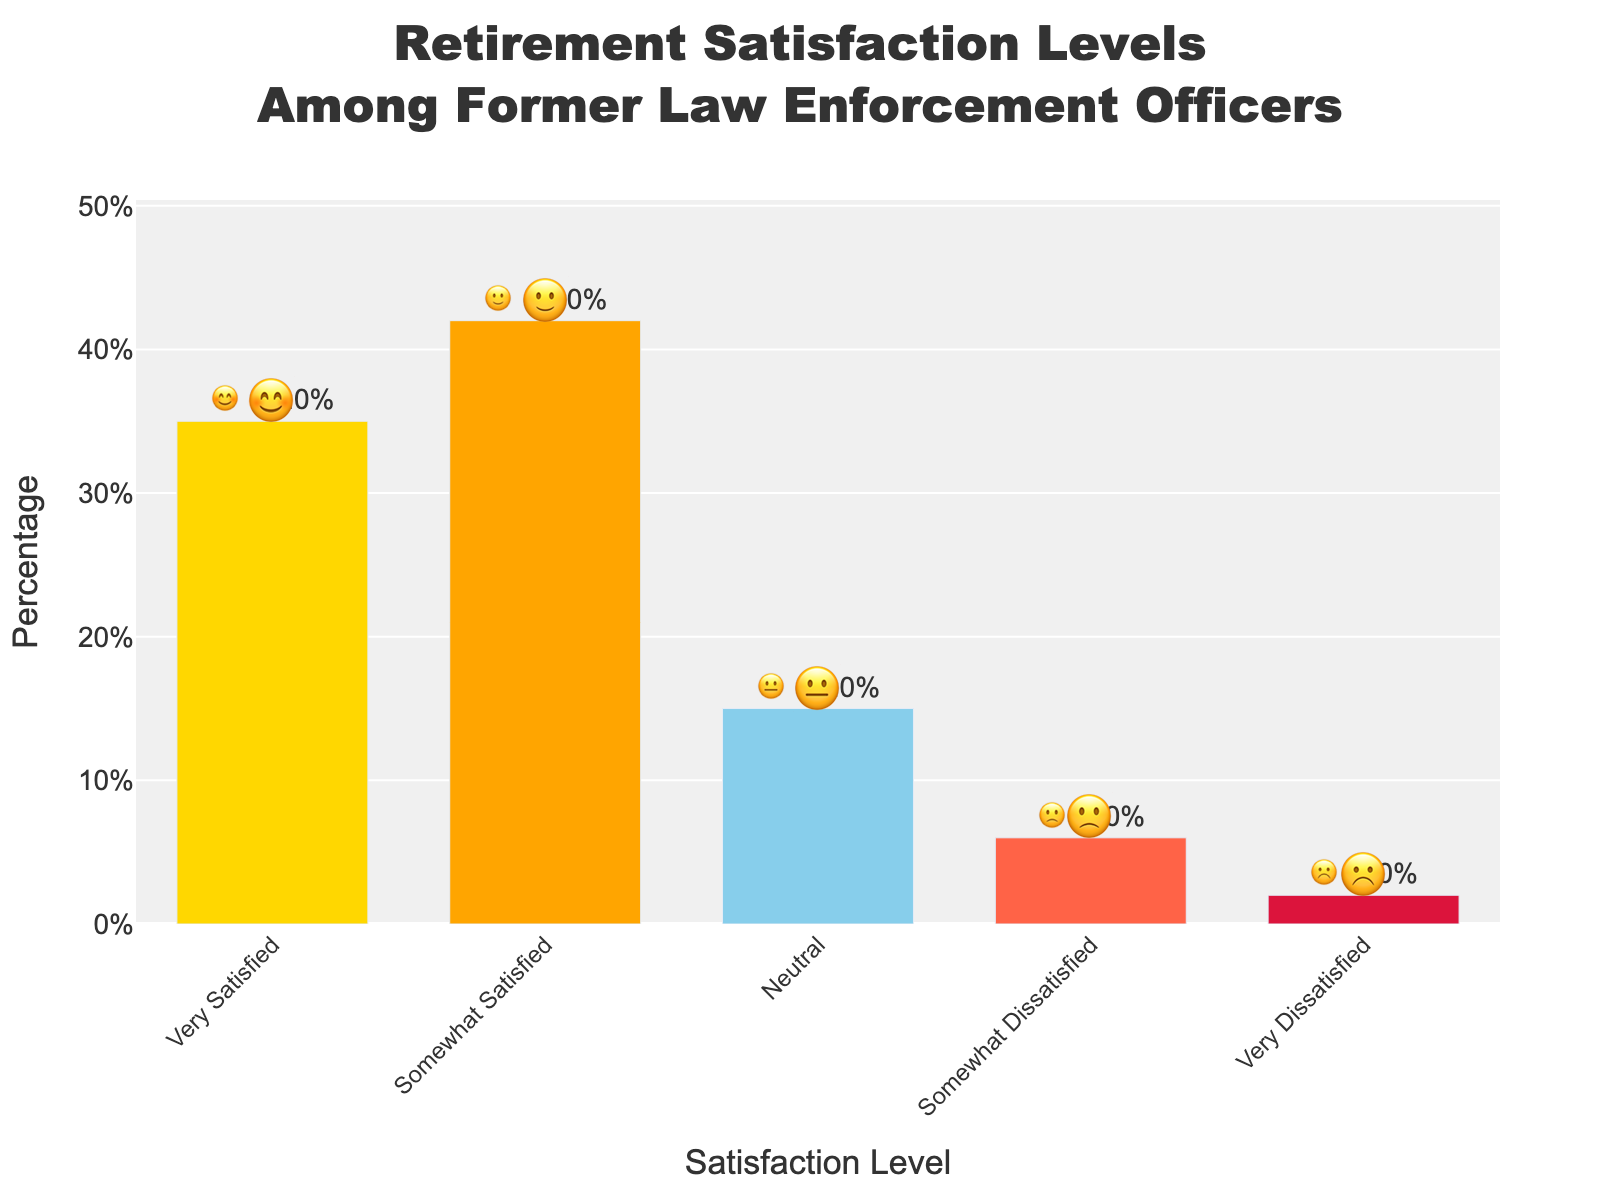What is the highest retirement satisfaction level among former law enforcement officers? The highest retirement satisfaction level can be seen by identifying the bar with the greatest height in the plot. The 'Very Satisfied' bar is highest, indicating it has the largest percentage.
Answer: Very Satisfied Which satisfaction level has the lowest percentage? The bar corresponding to the satisfaction level with the smallest height represents the lowest percentage. The 'Very Dissatisfied' bar is the shortest.
Answer: Very Dissatisfied What is the combined percentage of officers who are somewhat and very satisfied with their retirement? Adding the percentages for 'Somewhat Satisfied' and 'Very Satisfied', 42% and 35% respectively, gives the combined percentage.
Answer: 77% How much higher is the satisfaction of the 'Somewhat Satisfied' group compared to the 'Neutral' group? Subtract the percentage of the 'Neutral' group from the percentage of the 'Somewhat Satisfied' group (42% - 15% = 27%).
Answer: 27% What is the title of the chart? The title is displayed at the top of the chart. It reads, "Retirement Satisfaction Levels Among Former Law Enforcement Officers."
Answer: Retirement Satisfaction Levels Among Former Law Enforcement Officers Which two satisfaction levels are closest in percentage? By examining the heights of the bars and their corresponding percentages, 'Neutral' (15%) and 'Somewhat Dissatisfied' (6%) are closest. Their difference is minimal compared to others.
Answer: Neutral and Somewhat Dissatisfied How many percentage points make up the combined total of 'Very Dissatisfied' and 'Somewhat Dissatisfied'? Sum the percentages for 'Very Dissatisfied' and 'Somewhat Dissatisfied' (2% + 6%) to get the total.
Answer: 8% Which satisfaction level has an emoji that represents neutral or no strong feelings? The emoji associated with the 'Neutral' bar is 😐, representing no strong feelings.
Answer: Neutral What color is used for the bar representing 'Somewhat Satisfied'? The color of each bar can be observed directly in the chart. 'Somewhat Satisfied' is represented by an orange bar.
Answer: Orange What's the difference in percentage points between the 'Very Satisfied' group and the 'Very Dissatisfied' group? Subtract the percentage of the 'Very Dissatisfied' group from the percentage of the 'Very Satisfied' group (35% - 2%).
Answer: 33% 